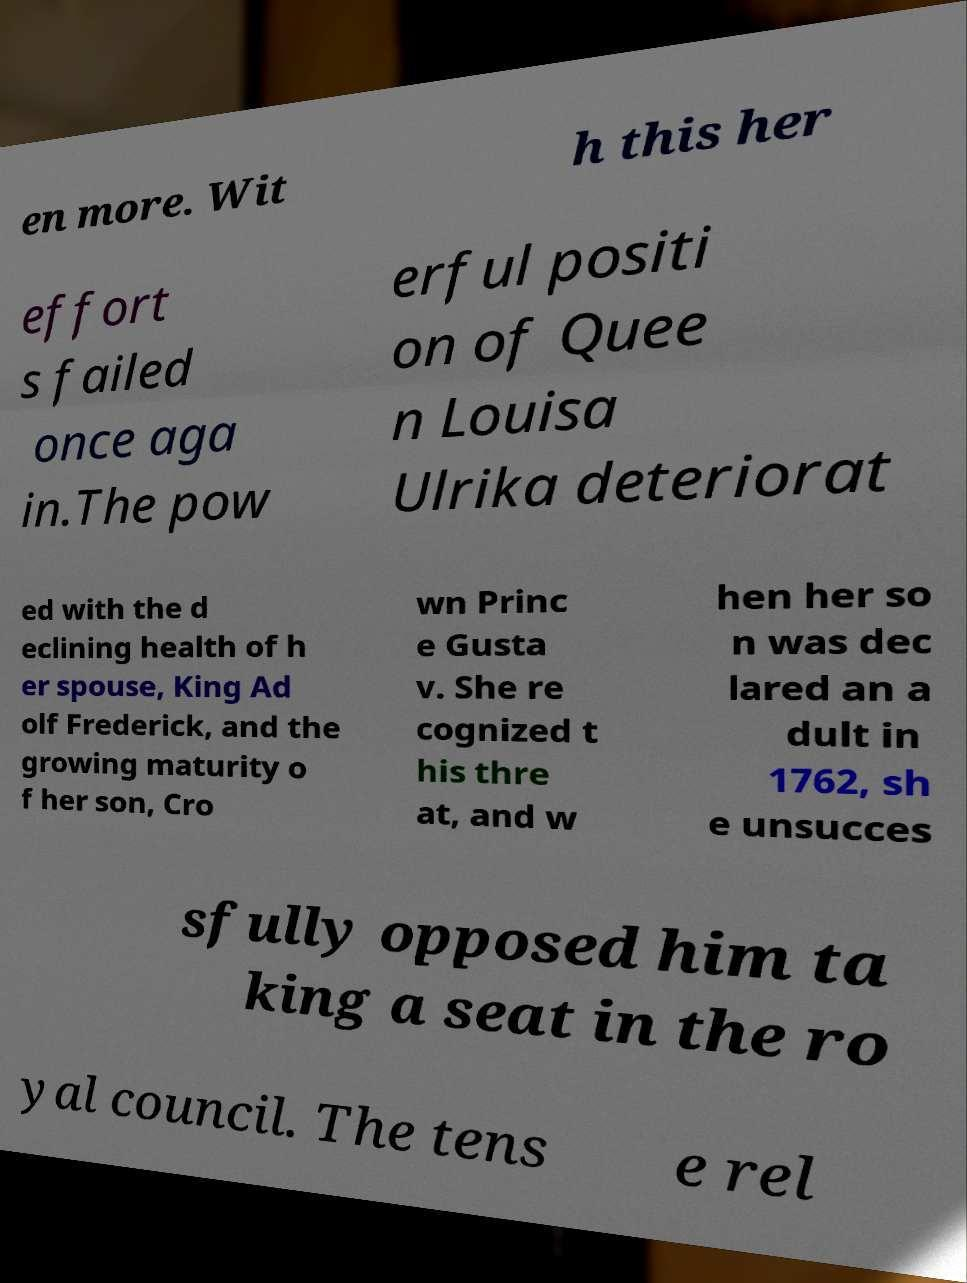For documentation purposes, I need the text within this image transcribed. Could you provide that? en more. Wit h this her effort s failed once aga in.The pow erful positi on of Quee n Louisa Ulrika deteriorat ed with the d eclining health of h er spouse, King Ad olf Frederick, and the growing maturity o f her son, Cro wn Princ e Gusta v. She re cognized t his thre at, and w hen her so n was dec lared an a dult in 1762, sh e unsucces sfully opposed him ta king a seat in the ro yal council. The tens e rel 